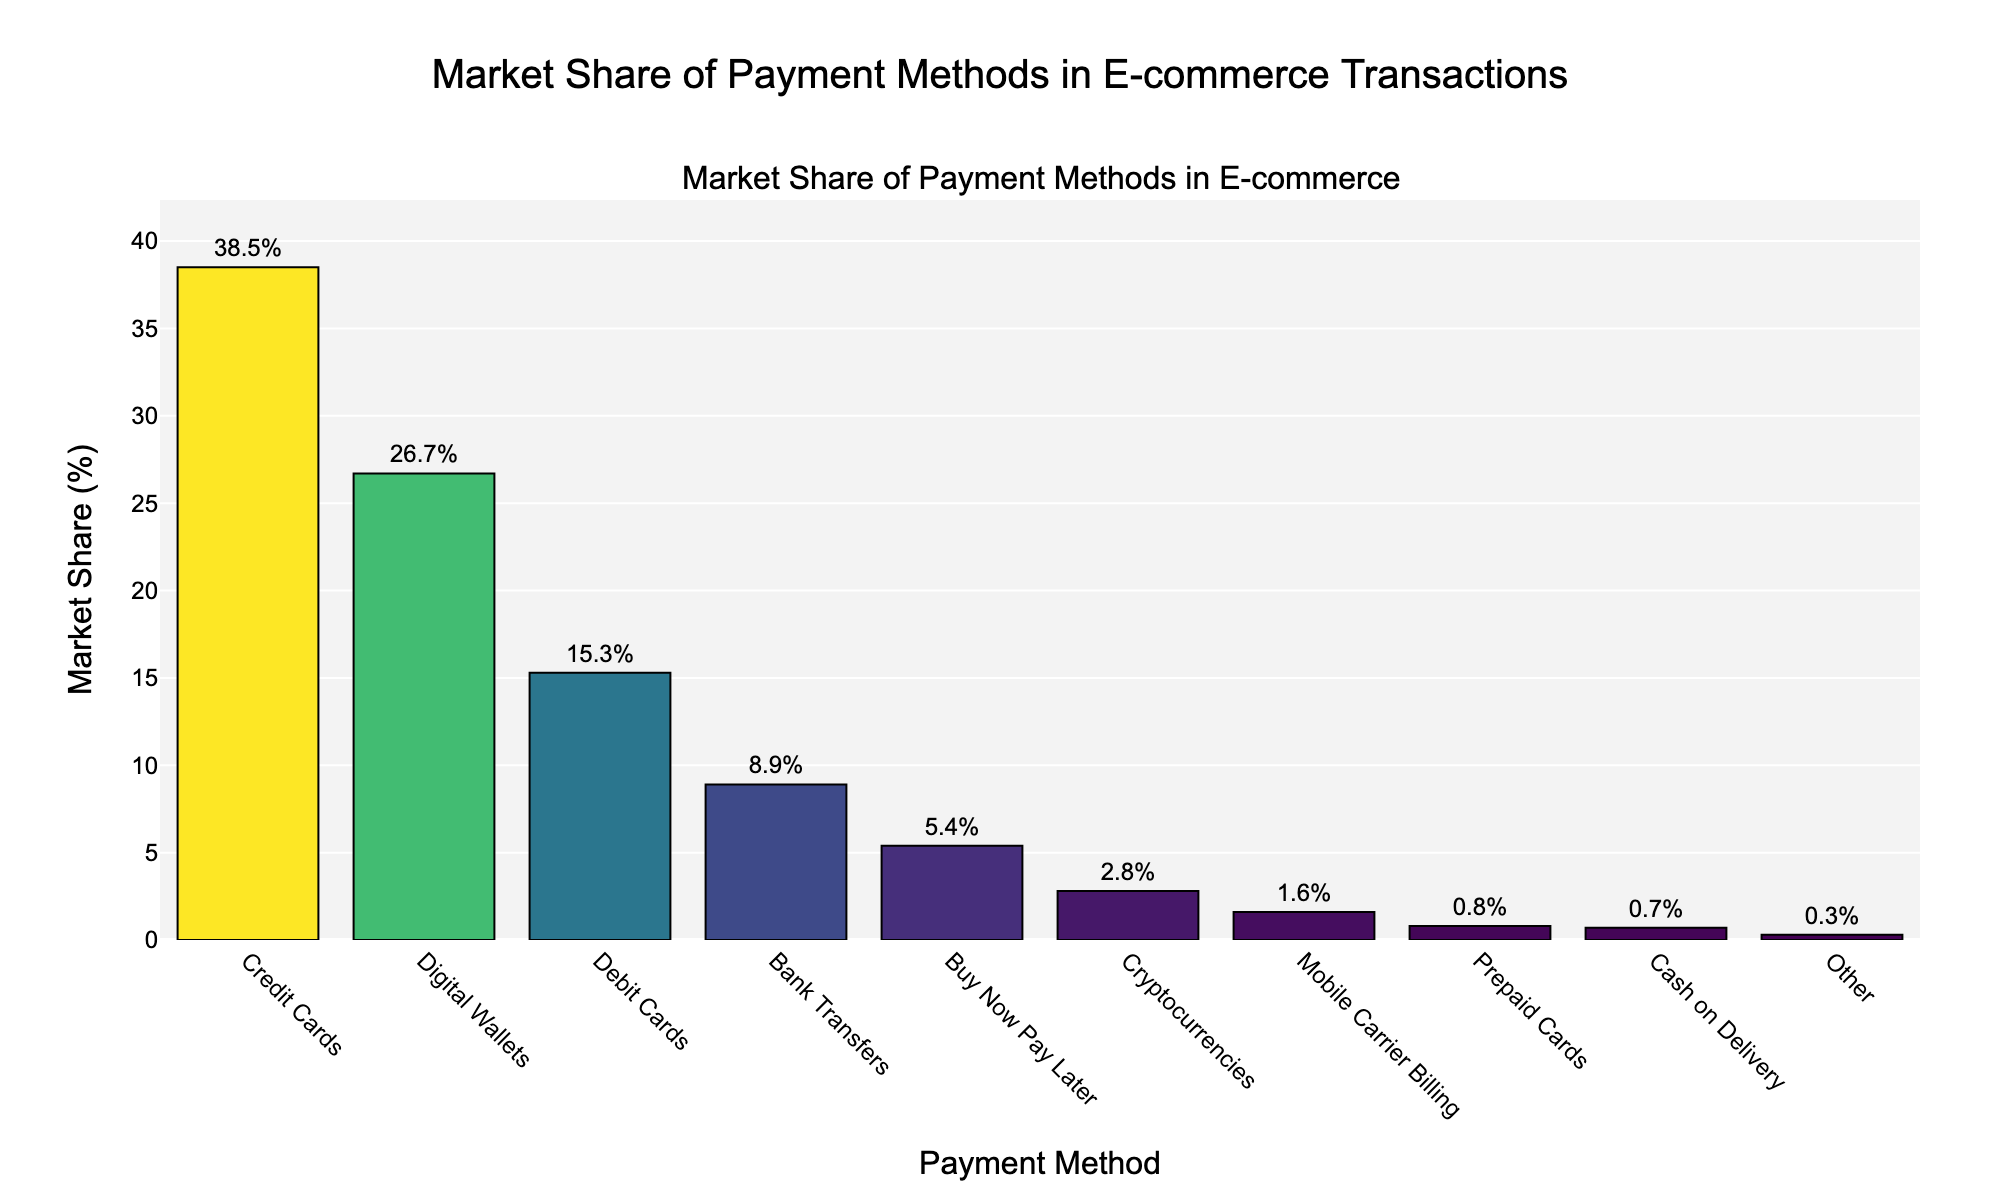Which payment method has the highest market share in e-commerce transactions? The highest bar in the chart represents the payment method with the highest market share, which is labeled with the market share percentage.
Answer: Credit Cards Compare the market shares of Digital Wallets and Debit Cards. Which one is higher and by how much? Digital Wallets have a market share of 26.7%, and Debit Cards have a market share of 15.3%. Subtract the market share of Debit Cards from that of Digital Wallets to find the difference: 26.7% - 15.3% = 11.4%.
Answer: Digital Wallets by 11.4% What is the combined market share of Credit Cards and Digital Wallets? Add the market share percentages of Credit Cards (38.5%) and Digital Wallets (26.7%) together to get the combined market share: 38.5% + 26.7% = 65.2%.
Answer: 65.2% Which payment method has the smallest market share in e-commerce transactions, and what is its percentage? The shortest bar in the chart represents the payment method with the smallest market share, labeled with 0.3%. This corresponds to the "Other" payment method.
Answer: Other, 0.3% How does the market share of Buy Now Pay Later compare to that of Cryptocurrencies? The chart shows that Buy Now Pay Later has a market share of 5.4%, while Cryptocurrencies have a market share of 2.8%. To compare, subtract 2.8% from 5.4%: 5.4% - 2.8% = 2.6%.
Answer: Buy Now Pay Later by 2.6% What is the average market share of the three smallest payment methods? Identify the three payment methods with the smallest market shares: Other (0.3%), Cash on Delivery (0.7%), and Prepaid Cards (0.8%). Calculate the average by adding these percentages and dividing by 3: (0.3% + 0.7% + 0.8%) / 3 = 1.8% / 3 = 0.6%.
Answer: 0.6% By how much does the market share of Bank Transfers differ from that of Prepaid Cards? Bank Transfers have a market share of 8.9%, and Prepaid Cards have a market share of 0.8%. Subtract the latter from the former: 8.9% - 0.8% = 8.1%.
Answer: 8.1% What is the visual appearance (color) of the bar representing Debit Cards compared to that of Digital Wallets? On the chart, bars are colored in a gradient of Viridis, where higher percentages are generally of a darker color. Debit Cards have a lighter color than Digital Wallets, indicating a lower market share.
Answer: Lighter How does the combined market share of Mobile Carrier Billing and Cryptocurrencies compare to Bank Transfers? Add the market shares of Mobile Carrier Billing (1.6%) and Cryptocurrencies (2.8%) to get the total: 1.6% + 2.8% = 4.4%. Then compare this to Bank Transfers' market share of 8.9%.
Answer: Lower by 4.5% What is the difference between the highest and lowest market share percentages represented on the chart? The highest market share is for Credit Cards at 38.5%, and the lowest is for Other at 0.3%. Subtract the lowest from the highest: 38.5% - 0.3% = 38.2%.
Answer: 38.2% 